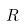Convert formula to latex. <formula><loc_0><loc_0><loc_500><loc_500>R</formula> 